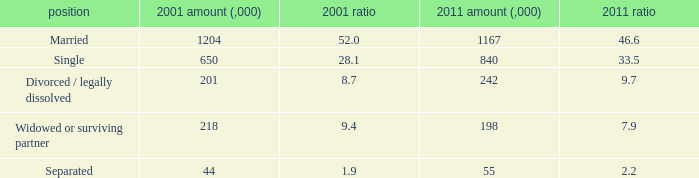What si the 2011 number (,000) when 2001 % is 28.1? 840.0. 